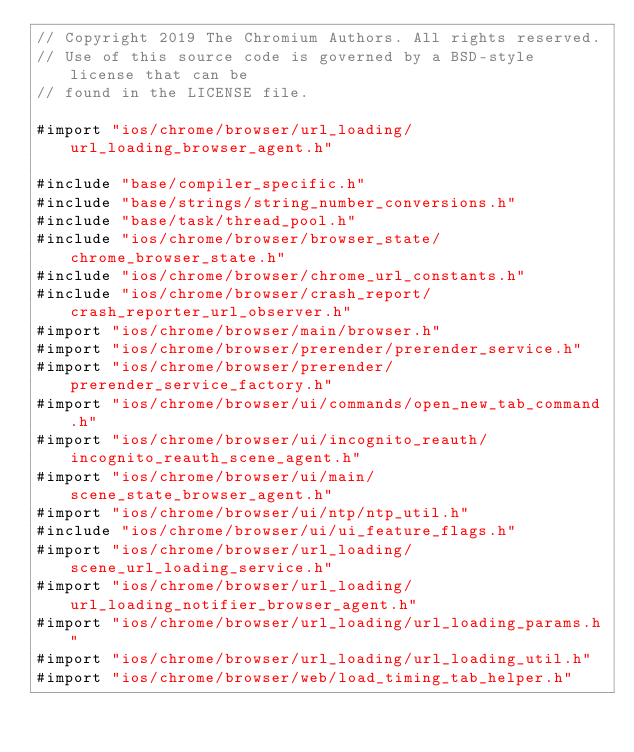Convert code to text. <code><loc_0><loc_0><loc_500><loc_500><_ObjectiveC_>// Copyright 2019 The Chromium Authors. All rights reserved.
// Use of this source code is governed by a BSD-style license that can be
// found in the LICENSE file.

#import "ios/chrome/browser/url_loading/url_loading_browser_agent.h"

#include "base/compiler_specific.h"
#include "base/strings/string_number_conversions.h"
#include "base/task/thread_pool.h"
#include "ios/chrome/browser/browser_state/chrome_browser_state.h"
#include "ios/chrome/browser/chrome_url_constants.h"
#include "ios/chrome/browser/crash_report/crash_reporter_url_observer.h"
#import "ios/chrome/browser/main/browser.h"
#import "ios/chrome/browser/prerender/prerender_service.h"
#import "ios/chrome/browser/prerender/prerender_service_factory.h"
#import "ios/chrome/browser/ui/commands/open_new_tab_command.h"
#import "ios/chrome/browser/ui/incognito_reauth/incognito_reauth_scene_agent.h"
#import "ios/chrome/browser/ui/main/scene_state_browser_agent.h"
#import "ios/chrome/browser/ui/ntp/ntp_util.h"
#include "ios/chrome/browser/ui/ui_feature_flags.h"
#import "ios/chrome/browser/url_loading/scene_url_loading_service.h"
#import "ios/chrome/browser/url_loading/url_loading_notifier_browser_agent.h"
#import "ios/chrome/browser/url_loading/url_loading_params.h"
#import "ios/chrome/browser/url_loading/url_loading_util.h"
#import "ios/chrome/browser/web/load_timing_tab_helper.h"</code> 